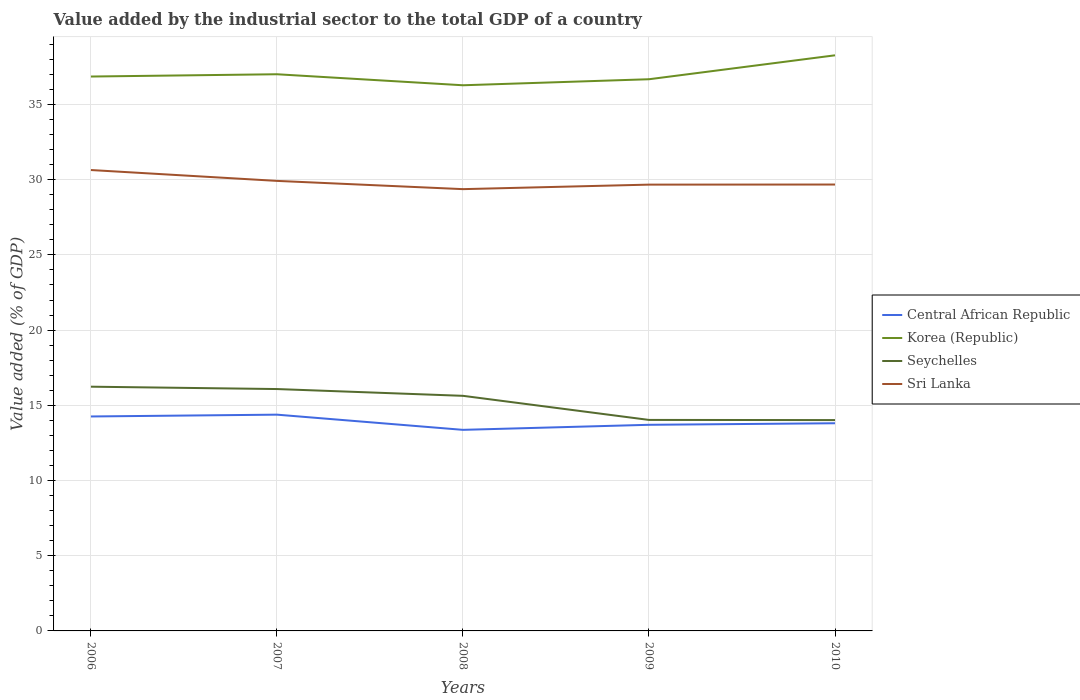How many different coloured lines are there?
Keep it short and to the point. 4. Across all years, what is the maximum value added by the industrial sector to the total GDP in Sri Lanka?
Offer a terse response. 29.37. What is the total value added by the industrial sector to the total GDP in Central African Republic in the graph?
Give a very brief answer. 0.55. What is the difference between the highest and the second highest value added by the industrial sector to the total GDP in Sri Lanka?
Keep it short and to the point. 1.27. What is the difference between the highest and the lowest value added by the industrial sector to the total GDP in Sri Lanka?
Offer a very short reply. 2. How many years are there in the graph?
Give a very brief answer. 5. Does the graph contain any zero values?
Keep it short and to the point. No. Does the graph contain grids?
Your answer should be very brief. Yes. Where does the legend appear in the graph?
Provide a succinct answer. Center right. How many legend labels are there?
Your answer should be very brief. 4. How are the legend labels stacked?
Your answer should be very brief. Vertical. What is the title of the graph?
Your answer should be compact. Value added by the industrial sector to the total GDP of a country. What is the label or title of the Y-axis?
Make the answer very short. Value added (% of GDP). What is the Value added (% of GDP) in Central African Republic in 2006?
Provide a short and direct response. 14.26. What is the Value added (% of GDP) of Korea (Republic) in 2006?
Your answer should be very brief. 36.86. What is the Value added (% of GDP) of Seychelles in 2006?
Your response must be concise. 16.24. What is the Value added (% of GDP) of Sri Lanka in 2006?
Provide a short and direct response. 30.64. What is the Value added (% of GDP) of Central African Republic in 2007?
Offer a very short reply. 14.38. What is the Value added (% of GDP) of Korea (Republic) in 2007?
Your answer should be compact. 37.01. What is the Value added (% of GDP) of Seychelles in 2007?
Your answer should be very brief. 16.08. What is the Value added (% of GDP) in Sri Lanka in 2007?
Give a very brief answer. 29.92. What is the Value added (% of GDP) of Central African Republic in 2008?
Provide a short and direct response. 13.37. What is the Value added (% of GDP) in Korea (Republic) in 2008?
Your response must be concise. 36.28. What is the Value added (% of GDP) in Seychelles in 2008?
Your answer should be very brief. 15.63. What is the Value added (% of GDP) of Sri Lanka in 2008?
Offer a very short reply. 29.37. What is the Value added (% of GDP) in Central African Republic in 2009?
Your response must be concise. 13.7. What is the Value added (% of GDP) of Korea (Republic) in 2009?
Provide a succinct answer. 36.68. What is the Value added (% of GDP) of Seychelles in 2009?
Make the answer very short. 14.03. What is the Value added (% of GDP) of Sri Lanka in 2009?
Your answer should be compact. 29.67. What is the Value added (% of GDP) of Central African Republic in 2010?
Provide a succinct answer. 13.81. What is the Value added (% of GDP) of Korea (Republic) in 2010?
Keep it short and to the point. 38.27. What is the Value added (% of GDP) of Seychelles in 2010?
Offer a terse response. 14.02. What is the Value added (% of GDP) in Sri Lanka in 2010?
Keep it short and to the point. 29.68. Across all years, what is the maximum Value added (% of GDP) in Central African Republic?
Your answer should be very brief. 14.38. Across all years, what is the maximum Value added (% of GDP) of Korea (Republic)?
Your answer should be very brief. 38.27. Across all years, what is the maximum Value added (% of GDP) in Seychelles?
Your answer should be compact. 16.24. Across all years, what is the maximum Value added (% of GDP) in Sri Lanka?
Keep it short and to the point. 30.64. Across all years, what is the minimum Value added (% of GDP) of Central African Republic?
Give a very brief answer. 13.37. Across all years, what is the minimum Value added (% of GDP) in Korea (Republic)?
Provide a succinct answer. 36.28. Across all years, what is the minimum Value added (% of GDP) of Seychelles?
Your answer should be very brief. 14.02. Across all years, what is the minimum Value added (% of GDP) of Sri Lanka?
Make the answer very short. 29.37. What is the total Value added (% of GDP) of Central African Republic in the graph?
Your answer should be compact. 69.52. What is the total Value added (% of GDP) of Korea (Republic) in the graph?
Provide a succinct answer. 185.09. What is the total Value added (% of GDP) in Seychelles in the graph?
Give a very brief answer. 75.99. What is the total Value added (% of GDP) of Sri Lanka in the graph?
Offer a very short reply. 149.28. What is the difference between the Value added (% of GDP) in Central African Republic in 2006 and that in 2007?
Your response must be concise. -0.12. What is the difference between the Value added (% of GDP) of Korea (Republic) in 2006 and that in 2007?
Give a very brief answer. -0.15. What is the difference between the Value added (% of GDP) in Seychelles in 2006 and that in 2007?
Your answer should be compact. 0.16. What is the difference between the Value added (% of GDP) of Sri Lanka in 2006 and that in 2007?
Give a very brief answer. 0.72. What is the difference between the Value added (% of GDP) in Central African Republic in 2006 and that in 2008?
Keep it short and to the point. 0.89. What is the difference between the Value added (% of GDP) in Korea (Republic) in 2006 and that in 2008?
Your answer should be very brief. 0.58. What is the difference between the Value added (% of GDP) in Seychelles in 2006 and that in 2008?
Offer a very short reply. 0.61. What is the difference between the Value added (% of GDP) of Sri Lanka in 2006 and that in 2008?
Your answer should be compact. 1.27. What is the difference between the Value added (% of GDP) in Central African Republic in 2006 and that in 2009?
Provide a short and direct response. 0.55. What is the difference between the Value added (% of GDP) of Korea (Republic) in 2006 and that in 2009?
Ensure brevity in your answer.  0.18. What is the difference between the Value added (% of GDP) of Seychelles in 2006 and that in 2009?
Your answer should be very brief. 2.21. What is the difference between the Value added (% of GDP) in Sri Lanka in 2006 and that in 2009?
Your answer should be compact. 0.97. What is the difference between the Value added (% of GDP) in Central African Republic in 2006 and that in 2010?
Give a very brief answer. 0.45. What is the difference between the Value added (% of GDP) of Korea (Republic) in 2006 and that in 2010?
Provide a short and direct response. -1.41. What is the difference between the Value added (% of GDP) of Seychelles in 2006 and that in 2010?
Make the answer very short. 2.22. What is the difference between the Value added (% of GDP) of Sri Lanka in 2006 and that in 2010?
Offer a very short reply. 0.96. What is the difference between the Value added (% of GDP) of Central African Republic in 2007 and that in 2008?
Provide a short and direct response. 1.01. What is the difference between the Value added (% of GDP) in Korea (Republic) in 2007 and that in 2008?
Ensure brevity in your answer.  0.73. What is the difference between the Value added (% of GDP) in Seychelles in 2007 and that in 2008?
Your answer should be compact. 0.45. What is the difference between the Value added (% of GDP) of Sri Lanka in 2007 and that in 2008?
Ensure brevity in your answer.  0.55. What is the difference between the Value added (% of GDP) of Central African Republic in 2007 and that in 2009?
Your answer should be compact. 0.67. What is the difference between the Value added (% of GDP) in Korea (Republic) in 2007 and that in 2009?
Your answer should be very brief. 0.33. What is the difference between the Value added (% of GDP) in Seychelles in 2007 and that in 2009?
Make the answer very short. 2.05. What is the difference between the Value added (% of GDP) of Sri Lanka in 2007 and that in 2009?
Provide a succinct answer. 0.25. What is the difference between the Value added (% of GDP) of Central African Republic in 2007 and that in 2010?
Provide a succinct answer. 0.57. What is the difference between the Value added (% of GDP) of Korea (Republic) in 2007 and that in 2010?
Offer a terse response. -1.26. What is the difference between the Value added (% of GDP) of Seychelles in 2007 and that in 2010?
Offer a terse response. 2.06. What is the difference between the Value added (% of GDP) in Sri Lanka in 2007 and that in 2010?
Offer a very short reply. 0.24. What is the difference between the Value added (% of GDP) of Central African Republic in 2008 and that in 2009?
Offer a very short reply. -0.34. What is the difference between the Value added (% of GDP) of Korea (Republic) in 2008 and that in 2009?
Offer a very short reply. -0.4. What is the difference between the Value added (% of GDP) in Seychelles in 2008 and that in 2009?
Keep it short and to the point. 1.6. What is the difference between the Value added (% of GDP) of Sri Lanka in 2008 and that in 2009?
Provide a succinct answer. -0.3. What is the difference between the Value added (% of GDP) in Central African Republic in 2008 and that in 2010?
Ensure brevity in your answer.  -0.44. What is the difference between the Value added (% of GDP) of Korea (Republic) in 2008 and that in 2010?
Your answer should be compact. -1.99. What is the difference between the Value added (% of GDP) in Seychelles in 2008 and that in 2010?
Offer a terse response. 1.61. What is the difference between the Value added (% of GDP) of Sri Lanka in 2008 and that in 2010?
Provide a succinct answer. -0.31. What is the difference between the Value added (% of GDP) in Central African Republic in 2009 and that in 2010?
Your answer should be compact. -0.1. What is the difference between the Value added (% of GDP) in Korea (Republic) in 2009 and that in 2010?
Offer a very short reply. -1.59. What is the difference between the Value added (% of GDP) of Seychelles in 2009 and that in 2010?
Offer a very short reply. 0.01. What is the difference between the Value added (% of GDP) in Sri Lanka in 2009 and that in 2010?
Keep it short and to the point. -0.01. What is the difference between the Value added (% of GDP) in Central African Republic in 2006 and the Value added (% of GDP) in Korea (Republic) in 2007?
Make the answer very short. -22.75. What is the difference between the Value added (% of GDP) in Central African Republic in 2006 and the Value added (% of GDP) in Seychelles in 2007?
Keep it short and to the point. -1.82. What is the difference between the Value added (% of GDP) in Central African Republic in 2006 and the Value added (% of GDP) in Sri Lanka in 2007?
Your answer should be compact. -15.66. What is the difference between the Value added (% of GDP) of Korea (Republic) in 2006 and the Value added (% of GDP) of Seychelles in 2007?
Offer a terse response. 20.78. What is the difference between the Value added (% of GDP) of Korea (Republic) in 2006 and the Value added (% of GDP) of Sri Lanka in 2007?
Your answer should be compact. 6.94. What is the difference between the Value added (% of GDP) of Seychelles in 2006 and the Value added (% of GDP) of Sri Lanka in 2007?
Your response must be concise. -13.68. What is the difference between the Value added (% of GDP) in Central African Republic in 2006 and the Value added (% of GDP) in Korea (Republic) in 2008?
Offer a terse response. -22.02. What is the difference between the Value added (% of GDP) in Central African Republic in 2006 and the Value added (% of GDP) in Seychelles in 2008?
Keep it short and to the point. -1.37. What is the difference between the Value added (% of GDP) of Central African Republic in 2006 and the Value added (% of GDP) of Sri Lanka in 2008?
Provide a short and direct response. -15.11. What is the difference between the Value added (% of GDP) in Korea (Republic) in 2006 and the Value added (% of GDP) in Seychelles in 2008?
Ensure brevity in your answer.  21.23. What is the difference between the Value added (% of GDP) in Korea (Republic) in 2006 and the Value added (% of GDP) in Sri Lanka in 2008?
Provide a short and direct response. 7.49. What is the difference between the Value added (% of GDP) in Seychelles in 2006 and the Value added (% of GDP) in Sri Lanka in 2008?
Make the answer very short. -13.13. What is the difference between the Value added (% of GDP) of Central African Republic in 2006 and the Value added (% of GDP) of Korea (Republic) in 2009?
Your response must be concise. -22.42. What is the difference between the Value added (% of GDP) in Central African Republic in 2006 and the Value added (% of GDP) in Seychelles in 2009?
Your answer should be very brief. 0.23. What is the difference between the Value added (% of GDP) in Central African Republic in 2006 and the Value added (% of GDP) in Sri Lanka in 2009?
Your answer should be compact. -15.41. What is the difference between the Value added (% of GDP) in Korea (Republic) in 2006 and the Value added (% of GDP) in Seychelles in 2009?
Give a very brief answer. 22.83. What is the difference between the Value added (% of GDP) of Korea (Republic) in 2006 and the Value added (% of GDP) of Sri Lanka in 2009?
Your answer should be compact. 7.19. What is the difference between the Value added (% of GDP) in Seychelles in 2006 and the Value added (% of GDP) in Sri Lanka in 2009?
Your answer should be compact. -13.43. What is the difference between the Value added (% of GDP) in Central African Republic in 2006 and the Value added (% of GDP) in Korea (Republic) in 2010?
Provide a short and direct response. -24.01. What is the difference between the Value added (% of GDP) of Central African Republic in 2006 and the Value added (% of GDP) of Seychelles in 2010?
Your response must be concise. 0.24. What is the difference between the Value added (% of GDP) in Central African Republic in 2006 and the Value added (% of GDP) in Sri Lanka in 2010?
Give a very brief answer. -15.42. What is the difference between the Value added (% of GDP) in Korea (Republic) in 2006 and the Value added (% of GDP) in Seychelles in 2010?
Ensure brevity in your answer.  22.84. What is the difference between the Value added (% of GDP) of Korea (Republic) in 2006 and the Value added (% of GDP) of Sri Lanka in 2010?
Offer a very short reply. 7.18. What is the difference between the Value added (% of GDP) in Seychelles in 2006 and the Value added (% of GDP) in Sri Lanka in 2010?
Make the answer very short. -13.44. What is the difference between the Value added (% of GDP) of Central African Republic in 2007 and the Value added (% of GDP) of Korea (Republic) in 2008?
Provide a short and direct response. -21.9. What is the difference between the Value added (% of GDP) of Central African Republic in 2007 and the Value added (% of GDP) of Seychelles in 2008?
Your response must be concise. -1.25. What is the difference between the Value added (% of GDP) of Central African Republic in 2007 and the Value added (% of GDP) of Sri Lanka in 2008?
Provide a short and direct response. -14.99. What is the difference between the Value added (% of GDP) of Korea (Republic) in 2007 and the Value added (% of GDP) of Seychelles in 2008?
Offer a very short reply. 21.38. What is the difference between the Value added (% of GDP) in Korea (Republic) in 2007 and the Value added (% of GDP) in Sri Lanka in 2008?
Make the answer very short. 7.64. What is the difference between the Value added (% of GDP) of Seychelles in 2007 and the Value added (% of GDP) of Sri Lanka in 2008?
Your answer should be very brief. -13.29. What is the difference between the Value added (% of GDP) of Central African Republic in 2007 and the Value added (% of GDP) of Korea (Republic) in 2009?
Give a very brief answer. -22.3. What is the difference between the Value added (% of GDP) of Central African Republic in 2007 and the Value added (% of GDP) of Seychelles in 2009?
Your response must be concise. 0.35. What is the difference between the Value added (% of GDP) in Central African Republic in 2007 and the Value added (% of GDP) in Sri Lanka in 2009?
Provide a succinct answer. -15.29. What is the difference between the Value added (% of GDP) in Korea (Republic) in 2007 and the Value added (% of GDP) in Seychelles in 2009?
Keep it short and to the point. 22.98. What is the difference between the Value added (% of GDP) in Korea (Republic) in 2007 and the Value added (% of GDP) in Sri Lanka in 2009?
Keep it short and to the point. 7.34. What is the difference between the Value added (% of GDP) of Seychelles in 2007 and the Value added (% of GDP) of Sri Lanka in 2009?
Your response must be concise. -13.59. What is the difference between the Value added (% of GDP) of Central African Republic in 2007 and the Value added (% of GDP) of Korea (Republic) in 2010?
Ensure brevity in your answer.  -23.89. What is the difference between the Value added (% of GDP) of Central African Republic in 2007 and the Value added (% of GDP) of Seychelles in 2010?
Keep it short and to the point. 0.36. What is the difference between the Value added (% of GDP) in Central African Republic in 2007 and the Value added (% of GDP) in Sri Lanka in 2010?
Make the answer very short. -15.3. What is the difference between the Value added (% of GDP) in Korea (Republic) in 2007 and the Value added (% of GDP) in Seychelles in 2010?
Give a very brief answer. 22.99. What is the difference between the Value added (% of GDP) in Korea (Republic) in 2007 and the Value added (% of GDP) in Sri Lanka in 2010?
Your response must be concise. 7.33. What is the difference between the Value added (% of GDP) in Seychelles in 2007 and the Value added (% of GDP) in Sri Lanka in 2010?
Your answer should be compact. -13.6. What is the difference between the Value added (% of GDP) in Central African Republic in 2008 and the Value added (% of GDP) in Korea (Republic) in 2009?
Your answer should be very brief. -23.31. What is the difference between the Value added (% of GDP) of Central African Republic in 2008 and the Value added (% of GDP) of Seychelles in 2009?
Provide a succinct answer. -0.66. What is the difference between the Value added (% of GDP) in Central African Republic in 2008 and the Value added (% of GDP) in Sri Lanka in 2009?
Make the answer very short. -16.3. What is the difference between the Value added (% of GDP) of Korea (Republic) in 2008 and the Value added (% of GDP) of Seychelles in 2009?
Provide a succinct answer. 22.25. What is the difference between the Value added (% of GDP) in Korea (Republic) in 2008 and the Value added (% of GDP) in Sri Lanka in 2009?
Provide a succinct answer. 6.61. What is the difference between the Value added (% of GDP) of Seychelles in 2008 and the Value added (% of GDP) of Sri Lanka in 2009?
Give a very brief answer. -14.04. What is the difference between the Value added (% of GDP) of Central African Republic in 2008 and the Value added (% of GDP) of Korea (Republic) in 2010?
Provide a succinct answer. -24.9. What is the difference between the Value added (% of GDP) in Central African Republic in 2008 and the Value added (% of GDP) in Seychelles in 2010?
Your response must be concise. -0.65. What is the difference between the Value added (% of GDP) in Central African Republic in 2008 and the Value added (% of GDP) in Sri Lanka in 2010?
Your response must be concise. -16.31. What is the difference between the Value added (% of GDP) in Korea (Republic) in 2008 and the Value added (% of GDP) in Seychelles in 2010?
Provide a short and direct response. 22.26. What is the difference between the Value added (% of GDP) of Korea (Republic) in 2008 and the Value added (% of GDP) of Sri Lanka in 2010?
Make the answer very short. 6.6. What is the difference between the Value added (% of GDP) of Seychelles in 2008 and the Value added (% of GDP) of Sri Lanka in 2010?
Your answer should be compact. -14.05. What is the difference between the Value added (% of GDP) in Central African Republic in 2009 and the Value added (% of GDP) in Korea (Republic) in 2010?
Your answer should be very brief. -24.57. What is the difference between the Value added (% of GDP) in Central African Republic in 2009 and the Value added (% of GDP) in Seychelles in 2010?
Make the answer very short. -0.31. What is the difference between the Value added (% of GDP) in Central African Republic in 2009 and the Value added (% of GDP) in Sri Lanka in 2010?
Offer a very short reply. -15.97. What is the difference between the Value added (% of GDP) in Korea (Republic) in 2009 and the Value added (% of GDP) in Seychelles in 2010?
Your response must be concise. 22.66. What is the difference between the Value added (% of GDP) in Korea (Republic) in 2009 and the Value added (% of GDP) in Sri Lanka in 2010?
Keep it short and to the point. 7. What is the difference between the Value added (% of GDP) in Seychelles in 2009 and the Value added (% of GDP) in Sri Lanka in 2010?
Your answer should be very brief. -15.65. What is the average Value added (% of GDP) in Central African Republic per year?
Your response must be concise. 13.9. What is the average Value added (% of GDP) in Korea (Republic) per year?
Offer a terse response. 37.02. What is the average Value added (% of GDP) of Seychelles per year?
Offer a terse response. 15.2. What is the average Value added (% of GDP) in Sri Lanka per year?
Your answer should be compact. 29.86. In the year 2006, what is the difference between the Value added (% of GDP) of Central African Republic and Value added (% of GDP) of Korea (Republic)?
Make the answer very short. -22.6. In the year 2006, what is the difference between the Value added (% of GDP) of Central African Republic and Value added (% of GDP) of Seychelles?
Give a very brief answer. -1.98. In the year 2006, what is the difference between the Value added (% of GDP) of Central African Republic and Value added (% of GDP) of Sri Lanka?
Give a very brief answer. -16.38. In the year 2006, what is the difference between the Value added (% of GDP) of Korea (Republic) and Value added (% of GDP) of Seychelles?
Your answer should be very brief. 20.62. In the year 2006, what is the difference between the Value added (% of GDP) of Korea (Republic) and Value added (% of GDP) of Sri Lanka?
Your answer should be compact. 6.22. In the year 2006, what is the difference between the Value added (% of GDP) in Seychelles and Value added (% of GDP) in Sri Lanka?
Your response must be concise. -14.4. In the year 2007, what is the difference between the Value added (% of GDP) in Central African Republic and Value added (% of GDP) in Korea (Republic)?
Give a very brief answer. -22.63. In the year 2007, what is the difference between the Value added (% of GDP) of Central African Republic and Value added (% of GDP) of Seychelles?
Ensure brevity in your answer.  -1.7. In the year 2007, what is the difference between the Value added (% of GDP) in Central African Republic and Value added (% of GDP) in Sri Lanka?
Keep it short and to the point. -15.54. In the year 2007, what is the difference between the Value added (% of GDP) in Korea (Republic) and Value added (% of GDP) in Seychelles?
Give a very brief answer. 20.93. In the year 2007, what is the difference between the Value added (% of GDP) in Korea (Republic) and Value added (% of GDP) in Sri Lanka?
Your answer should be very brief. 7.09. In the year 2007, what is the difference between the Value added (% of GDP) in Seychelles and Value added (% of GDP) in Sri Lanka?
Make the answer very short. -13.84. In the year 2008, what is the difference between the Value added (% of GDP) of Central African Republic and Value added (% of GDP) of Korea (Republic)?
Offer a very short reply. -22.91. In the year 2008, what is the difference between the Value added (% of GDP) in Central African Republic and Value added (% of GDP) in Seychelles?
Keep it short and to the point. -2.26. In the year 2008, what is the difference between the Value added (% of GDP) in Central African Republic and Value added (% of GDP) in Sri Lanka?
Keep it short and to the point. -16. In the year 2008, what is the difference between the Value added (% of GDP) in Korea (Republic) and Value added (% of GDP) in Seychelles?
Offer a terse response. 20.65. In the year 2008, what is the difference between the Value added (% of GDP) in Korea (Republic) and Value added (% of GDP) in Sri Lanka?
Offer a very short reply. 6.91. In the year 2008, what is the difference between the Value added (% of GDP) of Seychelles and Value added (% of GDP) of Sri Lanka?
Provide a short and direct response. -13.74. In the year 2009, what is the difference between the Value added (% of GDP) of Central African Republic and Value added (% of GDP) of Korea (Republic)?
Your answer should be very brief. -22.97. In the year 2009, what is the difference between the Value added (% of GDP) in Central African Republic and Value added (% of GDP) in Seychelles?
Offer a very short reply. -0.32. In the year 2009, what is the difference between the Value added (% of GDP) of Central African Republic and Value added (% of GDP) of Sri Lanka?
Offer a very short reply. -15.97. In the year 2009, what is the difference between the Value added (% of GDP) of Korea (Republic) and Value added (% of GDP) of Seychelles?
Provide a succinct answer. 22.65. In the year 2009, what is the difference between the Value added (% of GDP) of Korea (Republic) and Value added (% of GDP) of Sri Lanka?
Your answer should be very brief. 7.01. In the year 2009, what is the difference between the Value added (% of GDP) in Seychelles and Value added (% of GDP) in Sri Lanka?
Keep it short and to the point. -15.64. In the year 2010, what is the difference between the Value added (% of GDP) in Central African Republic and Value added (% of GDP) in Korea (Republic)?
Ensure brevity in your answer.  -24.46. In the year 2010, what is the difference between the Value added (% of GDP) of Central African Republic and Value added (% of GDP) of Seychelles?
Your response must be concise. -0.21. In the year 2010, what is the difference between the Value added (% of GDP) of Central African Republic and Value added (% of GDP) of Sri Lanka?
Your answer should be very brief. -15.87. In the year 2010, what is the difference between the Value added (% of GDP) of Korea (Republic) and Value added (% of GDP) of Seychelles?
Offer a terse response. 24.25. In the year 2010, what is the difference between the Value added (% of GDP) in Korea (Republic) and Value added (% of GDP) in Sri Lanka?
Offer a very short reply. 8.59. In the year 2010, what is the difference between the Value added (% of GDP) in Seychelles and Value added (% of GDP) in Sri Lanka?
Offer a terse response. -15.66. What is the ratio of the Value added (% of GDP) in Korea (Republic) in 2006 to that in 2007?
Offer a very short reply. 1. What is the ratio of the Value added (% of GDP) of Seychelles in 2006 to that in 2007?
Make the answer very short. 1.01. What is the ratio of the Value added (% of GDP) of Sri Lanka in 2006 to that in 2007?
Provide a succinct answer. 1.02. What is the ratio of the Value added (% of GDP) in Central African Republic in 2006 to that in 2008?
Your response must be concise. 1.07. What is the ratio of the Value added (% of GDP) in Seychelles in 2006 to that in 2008?
Make the answer very short. 1.04. What is the ratio of the Value added (% of GDP) of Sri Lanka in 2006 to that in 2008?
Make the answer very short. 1.04. What is the ratio of the Value added (% of GDP) of Central African Republic in 2006 to that in 2009?
Offer a very short reply. 1.04. What is the ratio of the Value added (% of GDP) in Seychelles in 2006 to that in 2009?
Offer a terse response. 1.16. What is the ratio of the Value added (% of GDP) of Sri Lanka in 2006 to that in 2009?
Provide a succinct answer. 1.03. What is the ratio of the Value added (% of GDP) of Central African Republic in 2006 to that in 2010?
Make the answer very short. 1.03. What is the ratio of the Value added (% of GDP) of Korea (Republic) in 2006 to that in 2010?
Make the answer very short. 0.96. What is the ratio of the Value added (% of GDP) in Seychelles in 2006 to that in 2010?
Ensure brevity in your answer.  1.16. What is the ratio of the Value added (% of GDP) of Sri Lanka in 2006 to that in 2010?
Your answer should be compact. 1.03. What is the ratio of the Value added (% of GDP) in Central African Republic in 2007 to that in 2008?
Offer a terse response. 1.08. What is the ratio of the Value added (% of GDP) in Korea (Republic) in 2007 to that in 2008?
Your response must be concise. 1.02. What is the ratio of the Value added (% of GDP) of Seychelles in 2007 to that in 2008?
Ensure brevity in your answer.  1.03. What is the ratio of the Value added (% of GDP) of Sri Lanka in 2007 to that in 2008?
Ensure brevity in your answer.  1.02. What is the ratio of the Value added (% of GDP) in Central African Republic in 2007 to that in 2009?
Offer a terse response. 1.05. What is the ratio of the Value added (% of GDP) in Seychelles in 2007 to that in 2009?
Offer a very short reply. 1.15. What is the ratio of the Value added (% of GDP) of Sri Lanka in 2007 to that in 2009?
Your answer should be very brief. 1.01. What is the ratio of the Value added (% of GDP) in Central African Republic in 2007 to that in 2010?
Your answer should be compact. 1.04. What is the ratio of the Value added (% of GDP) in Korea (Republic) in 2007 to that in 2010?
Your answer should be very brief. 0.97. What is the ratio of the Value added (% of GDP) in Seychelles in 2007 to that in 2010?
Provide a short and direct response. 1.15. What is the ratio of the Value added (% of GDP) of Sri Lanka in 2007 to that in 2010?
Give a very brief answer. 1.01. What is the ratio of the Value added (% of GDP) in Central African Republic in 2008 to that in 2009?
Offer a terse response. 0.98. What is the ratio of the Value added (% of GDP) of Korea (Republic) in 2008 to that in 2009?
Keep it short and to the point. 0.99. What is the ratio of the Value added (% of GDP) of Seychelles in 2008 to that in 2009?
Make the answer very short. 1.11. What is the ratio of the Value added (% of GDP) of Sri Lanka in 2008 to that in 2009?
Offer a terse response. 0.99. What is the ratio of the Value added (% of GDP) in Central African Republic in 2008 to that in 2010?
Give a very brief answer. 0.97. What is the ratio of the Value added (% of GDP) in Korea (Republic) in 2008 to that in 2010?
Offer a terse response. 0.95. What is the ratio of the Value added (% of GDP) in Seychelles in 2008 to that in 2010?
Make the answer very short. 1.11. What is the ratio of the Value added (% of GDP) in Sri Lanka in 2008 to that in 2010?
Keep it short and to the point. 0.99. What is the ratio of the Value added (% of GDP) of Korea (Republic) in 2009 to that in 2010?
Ensure brevity in your answer.  0.96. What is the ratio of the Value added (% of GDP) in Seychelles in 2009 to that in 2010?
Provide a short and direct response. 1. What is the difference between the highest and the second highest Value added (% of GDP) of Central African Republic?
Make the answer very short. 0.12. What is the difference between the highest and the second highest Value added (% of GDP) of Korea (Republic)?
Offer a terse response. 1.26. What is the difference between the highest and the second highest Value added (% of GDP) of Seychelles?
Keep it short and to the point. 0.16. What is the difference between the highest and the second highest Value added (% of GDP) in Sri Lanka?
Offer a terse response. 0.72. What is the difference between the highest and the lowest Value added (% of GDP) of Central African Republic?
Your response must be concise. 1.01. What is the difference between the highest and the lowest Value added (% of GDP) of Korea (Republic)?
Provide a succinct answer. 1.99. What is the difference between the highest and the lowest Value added (% of GDP) of Seychelles?
Offer a very short reply. 2.22. What is the difference between the highest and the lowest Value added (% of GDP) of Sri Lanka?
Make the answer very short. 1.27. 